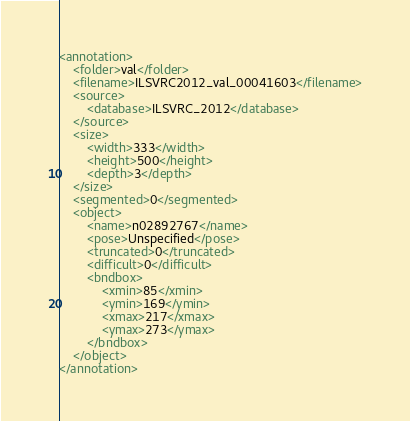<code> <loc_0><loc_0><loc_500><loc_500><_XML_><annotation>
	<folder>val</folder>
	<filename>ILSVRC2012_val_00041603</filename>
	<source>
		<database>ILSVRC_2012</database>
	</source>
	<size>
		<width>333</width>
		<height>500</height>
		<depth>3</depth>
	</size>
	<segmented>0</segmented>
	<object>
		<name>n02892767</name>
		<pose>Unspecified</pose>
		<truncated>0</truncated>
		<difficult>0</difficult>
		<bndbox>
			<xmin>85</xmin>
			<ymin>169</ymin>
			<xmax>217</xmax>
			<ymax>273</ymax>
		</bndbox>
	</object>
</annotation></code> 